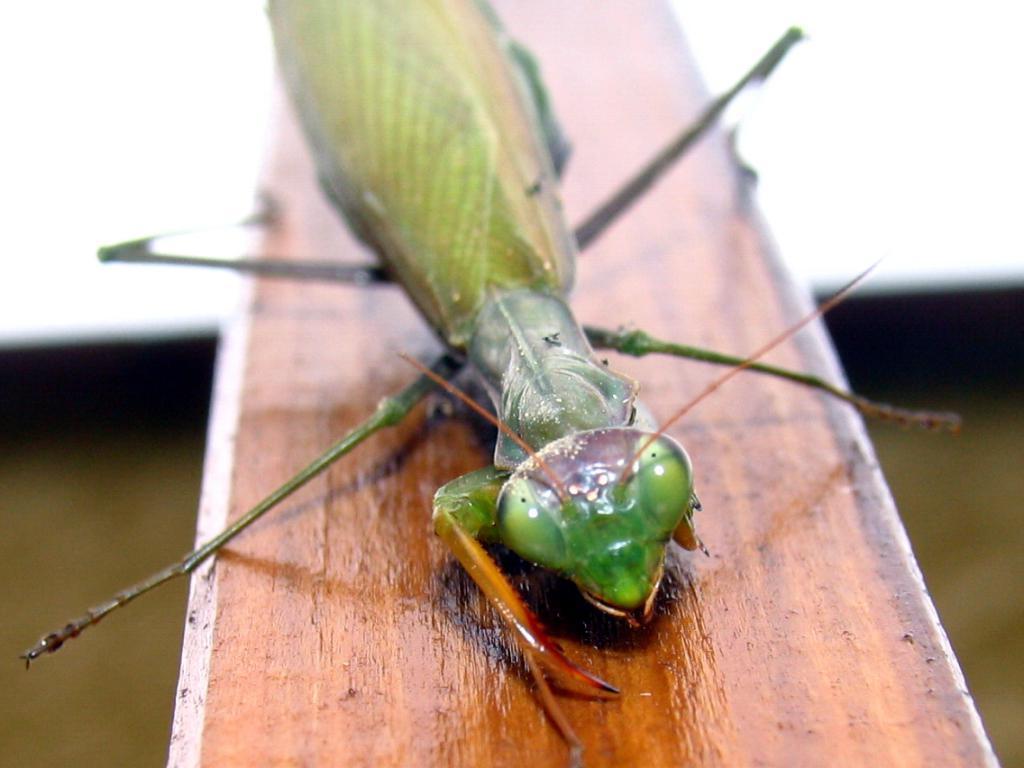Could you give a brief overview of what you see in this image? In this image we can see an insect on wooden surface. The background is blurry. 